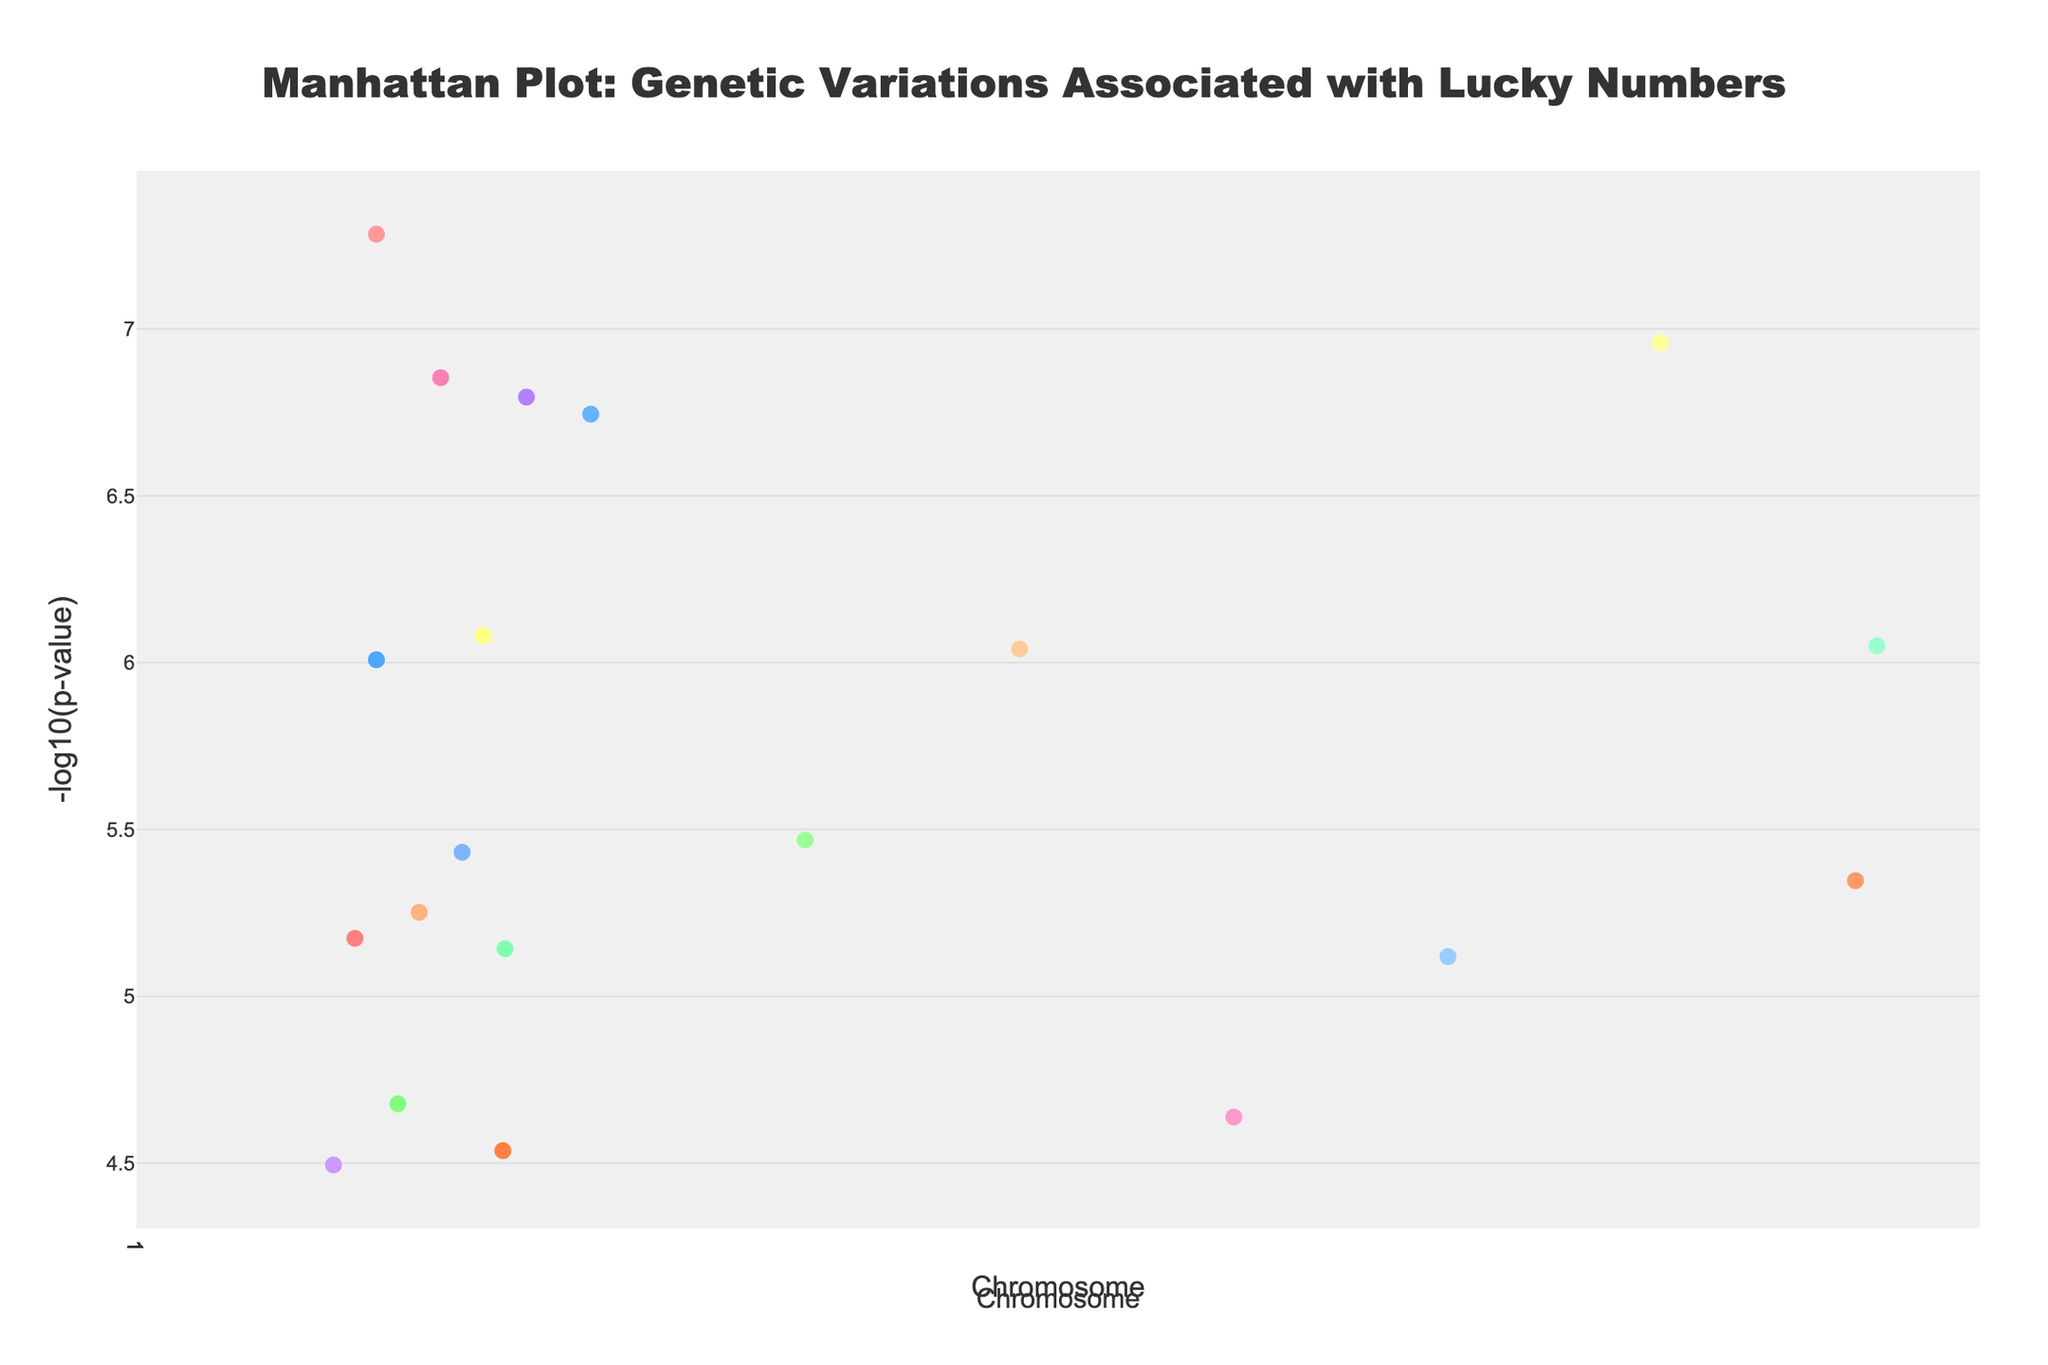What's the title of the figure? The title is often clearly visible at the top of a plot, illustrating the main theme or focus of the visual. In this case, the title describes the purpose of the plot related to genetic variations and lucky numbers.
Answer: Manhattan Plot: Genetic Variations Associated with Lucky Numbers Which chromosome has the lowest P-value indicated by the highest -log10(p-value)? The highest -log10(p-value) would visually appear as the highest point on the y-axis. Chromosome 1 has the highest point indicating the smallest P-value.
Answer: Chromosome 1 How many data points are below the -log10(p-value) threshold line? The threshold line is placed at y=7, and any point below this line does not reach the significant threshold. Counting these points visually confirms how many are below.
Answer: 17 Which gene corresponds to the lucky number 888, and in which culture is this number considered lucky? This question involves interpreting the hover text or annotations in the plot. The hover text will indicate which gene and the associated culture for the data point with lucky number 888.
Answer: ADRA2B, Hong Kong What's the number of chromosomes with at least one gene that has a significant association (-log10(p-value) above 7)? Significant associations are those above the threshold line at y=7. Counting the number of unique chromosomes that meet this criterion will provide the answer.
Answer: 4 Which gene represents the lucky number from the Japanese culture, and on which chromosome is it located? The plot displays detailed hover information for each point. Identifying the Japanese culture-related lucky number and referring to the corresponding gene and chromosome answers this question.
Answer: MAOA on Chromosome 2 Compare the P-values for genes FOXP2 and OXTR. Which gene exhibits a stronger association, and why? The stronger association corresponds to the lower P-value, seen as higher points when plotted as -log10(p-value). Comparing the two points identifies the one with the higher -log10(p-value).
Answer: OXTR because it has a higher -log10(p-value) Which chromosome has the data point located at the highest position (position number) along the x-axis, and what is the corresponding gene? The gene with the highest chromosome position value will be identified by checking the chromosome position values and matching it with associated genes.
Answer: Chromosome 9, CACNA1C What's the range of -log10(p-value) for the data points associated with Chromosome 5? To determine the range, find the highest and lowest -log10(p-value) points associated with Chromosome 5 and compute the difference. Range = max value - min value.
Answer: 4.6 (5.6 - 1.0) How does the genetic variation associated with lucky number 42 in British culture compare visually to the threshold on the plot? By looking at the y-value of the point (which represents -log10(p-value)) for lucky number 42 and comparing it to the threshold line at y=7, one determines if it is above or below the threshold.
Answer: Below 